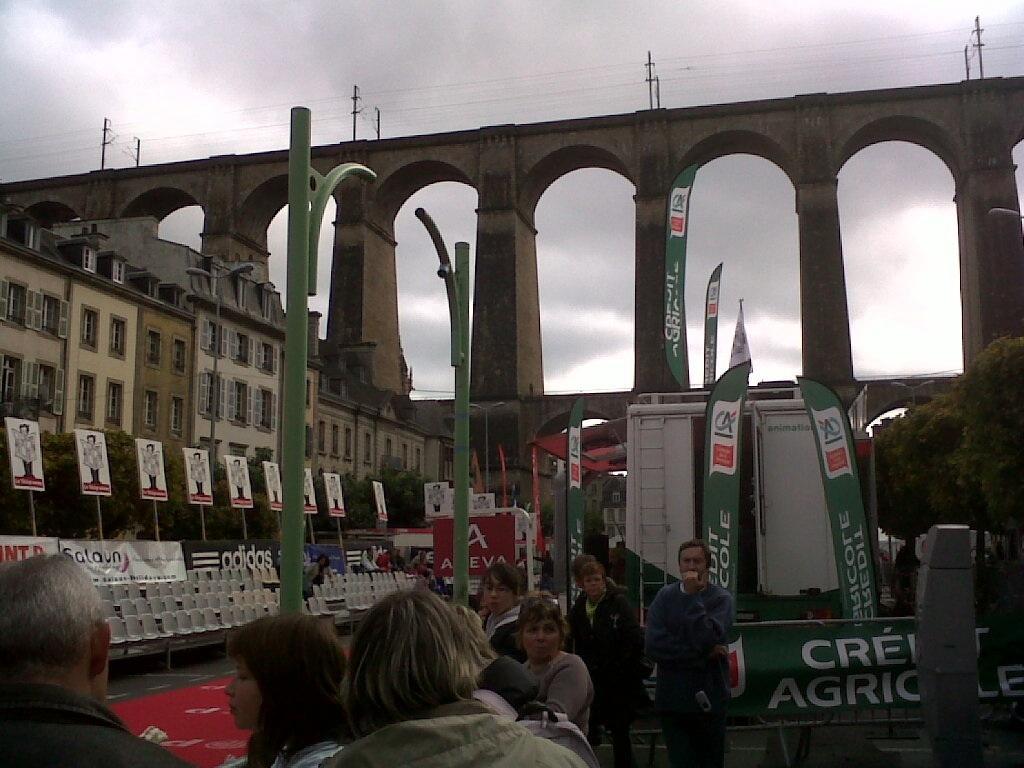Please provide a concise description of this image. In this picture I can observe some people standing on the land. On the left side there is a building and some chairs. In this picture I can observe a bridge. In the background there are some clouds in the sky. 